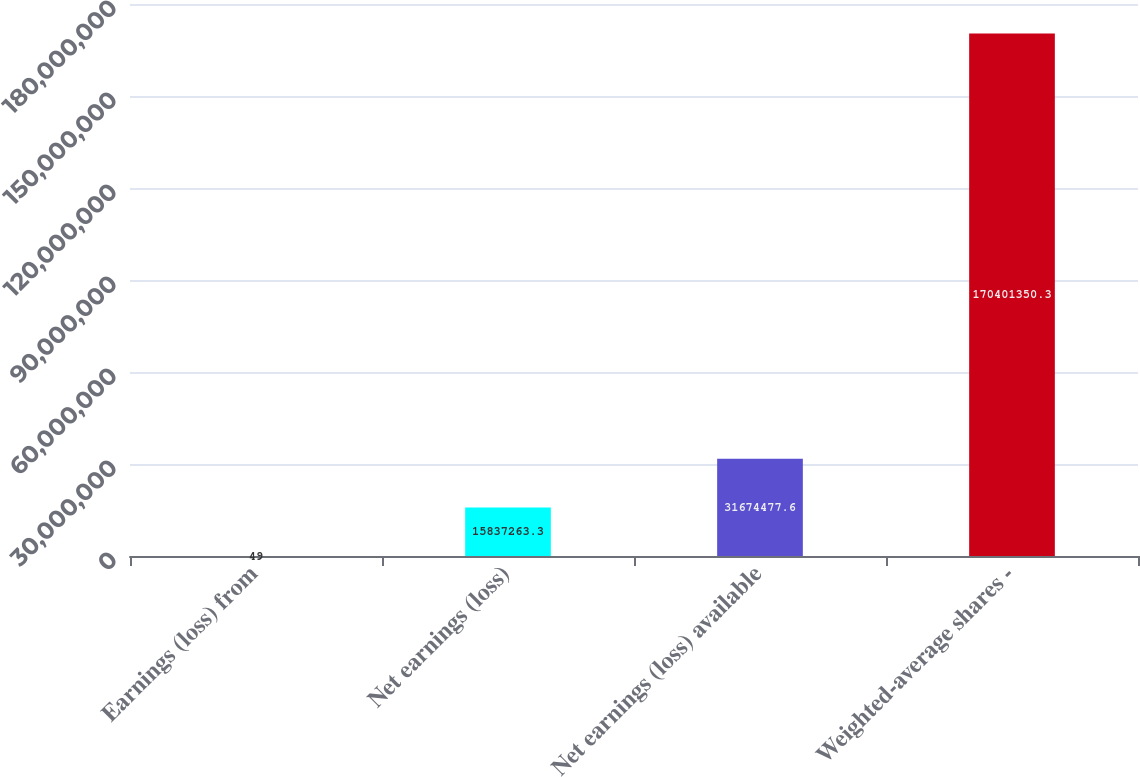Convert chart. <chart><loc_0><loc_0><loc_500><loc_500><bar_chart><fcel>Earnings (loss) from<fcel>Net earnings (loss)<fcel>Net earnings (loss) available<fcel>Weighted-average shares -<nl><fcel>49<fcel>1.58373e+07<fcel>3.16745e+07<fcel>1.70401e+08<nl></chart> 